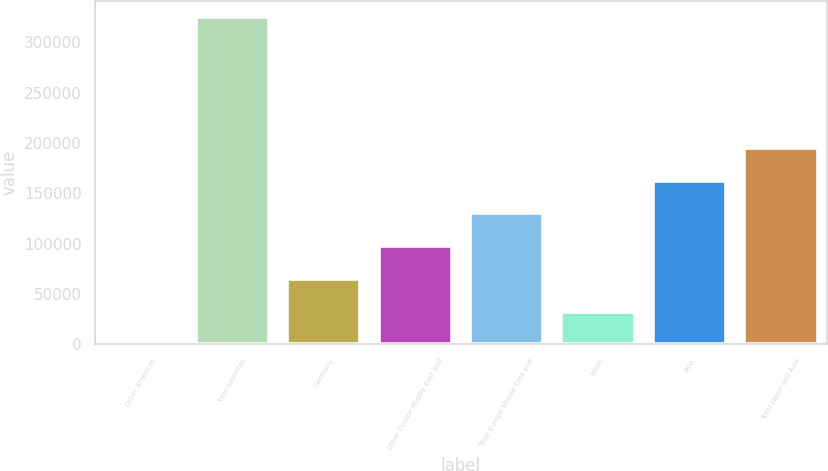<chart> <loc_0><loc_0><loc_500><loc_500><bar_chart><fcel>Other Americas<fcel>Total Americas<fcel>Germany<fcel>Other Europe Middle East and<fcel>Total Europe Middle East and<fcel>Japan<fcel>Asia<fcel>Total Japan and Asia<nl><fcel>108<fcel>325184<fcel>65123.2<fcel>97630.8<fcel>130138<fcel>32615.6<fcel>162646<fcel>195154<nl></chart> 